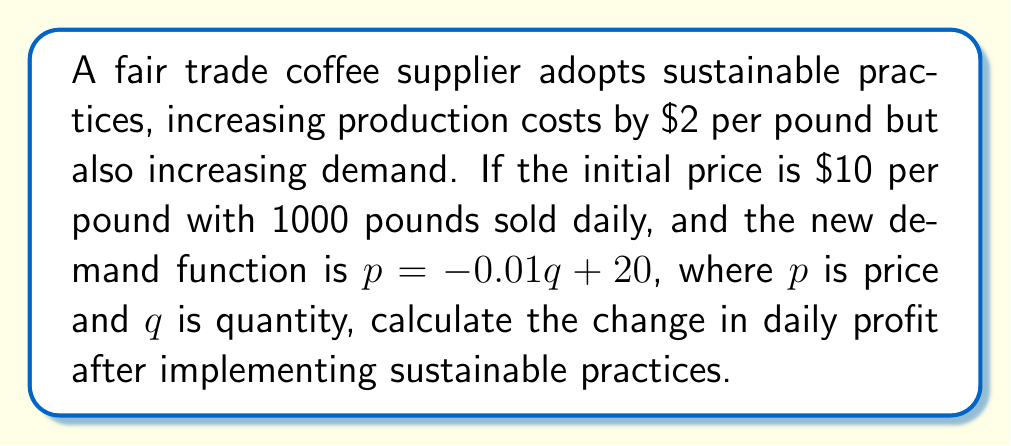Can you answer this question? 1. Initial profit:
   Profit = Revenue - Cost
   $\Pi_1 = 10 \cdot 1000 - 8 \cdot 1000 = 2000$

2. New cost per pound: $8 + 2 = 10$

3. Find new equilibrium using demand function:
   $p = -0.01q + 20$
   $10 = -0.01q + 20$
   $q = 1000$

4. New profit:
   $\Pi_2 = 10 \cdot 1000 - 10 \cdot 1000 = 0$

5. Change in profit:
   $\Delta\Pi = \Pi_2 - \Pi_1 = 0 - 2000 = -2000$
Answer: $-$2000 